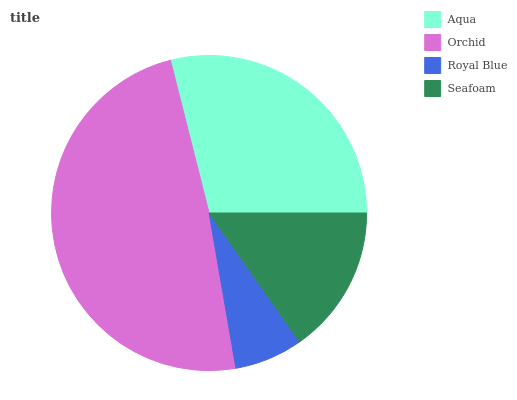Is Royal Blue the minimum?
Answer yes or no. Yes. Is Orchid the maximum?
Answer yes or no. Yes. Is Orchid the minimum?
Answer yes or no. No. Is Royal Blue the maximum?
Answer yes or no. No. Is Orchid greater than Royal Blue?
Answer yes or no. Yes. Is Royal Blue less than Orchid?
Answer yes or no. Yes. Is Royal Blue greater than Orchid?
Answer yes or no. No. Is Orchid less than Royal Blue?
Answer yes or no. No. Is Aqua the high median?
Answer yes or no. Yes. Is Seafoam the low median?
Answer yes or no. Yes. Is Seafoam the high median?
Answer yes or no. No. Is Royal Blue the low median?
Answer yes or no. No. 